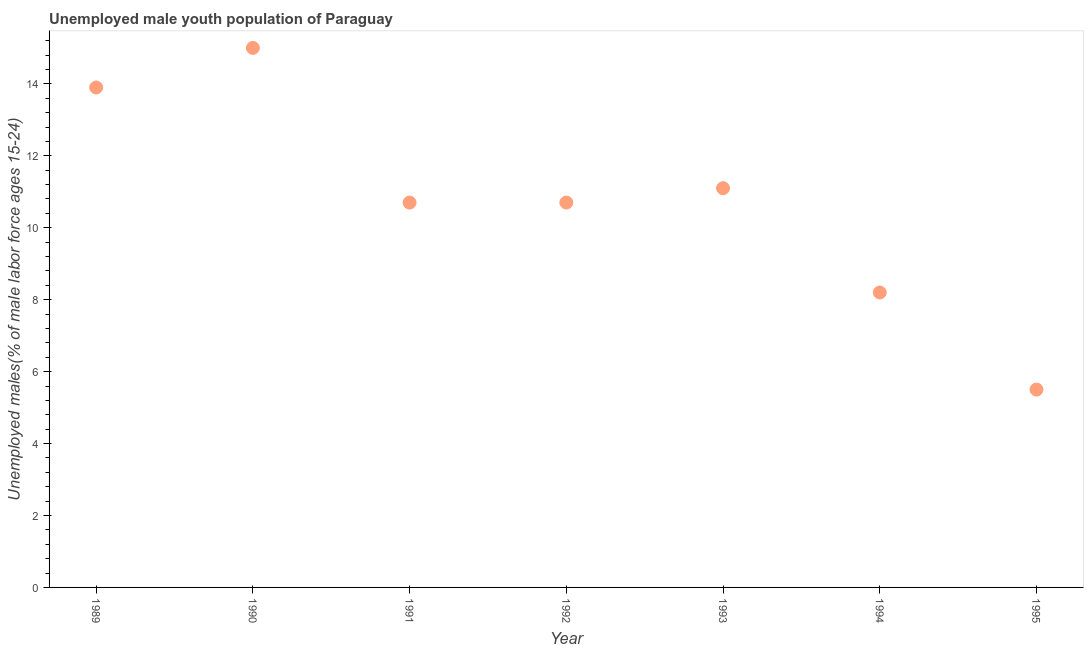What is the unemployed male youth in 1992?
Give a very brief answer. 10.7. Across all years, what is the minimum unemployed male youth?
Offer a terse response. 5.5. In which year was the unemployed male youth minimum?
Offer a terse response. 1995. What is the sum of the unemployed male youth?
Ensure brevity in your answer.  75.1. What is the difference between the unemployed male youth in 1989 and 1992?
Ensure brevity in your answer.  3.2. What is the average unemployed male youth per year?
Keep it short and to the point. 10.73. What is the median unemployed male youth?
Your answer should be compact. 10.7. Do a majority of the years between 1990 and 1994 (inclusive) have unemployed male youth greater than 5.2 %?
Your answer should be very brief. Yes. What is the ratio of the unemployed male youth in 1990 to that in 1993?
Your answer should be compact. 1.35. Is the unemployed male youth in 1991 less than that in 1992?
Your answer should be very brief. No. Is the difference between the unemployed male youth in 1990 and 1994 greater than the difference between any two years?
Keep it short and to the point. No. What is the difference between the highest and the second highest unemployed male youth?
Ensure brevity in your answer.  1.1. Is the sum of the unemployed male youth in 1989 and 1995 greater than the maximum unemployed male youth across all years?
Keep it short and to the point. Yes. How many dotlines are there?
Your response must be concise. 1. How many years are there in the graph?
Give a very brief answer. 7. What is the difference between two consecutive major ticks on the Y-axis?
Provide a short and direct response. 2. Does the graph contain any zero values?
Make the answer very short. No. What is the title of the graph?
Offer a terse response. Unemployed male youth population of Paraguay. What is the label or title of the Y-axis?
Offer a very short reply. Unemployed males(% of male labor force ages 15-24). What is the Unemployed males(% of male labor force ages 15-24) in 1989?
Give a very brief answer. 13.9. What is the Unemployed males(% of male labor force ages 15-24) in 1991?
Offer a terse response. 10.7. What is the Unemployed males(% of male labor force ages 15-24) in 1992?
Ensure brevity in your answer.  10.7. What is the Unemployed males(% of male labor force ages 15-24) in 1993?
Give a very brief answer. 11.1. What is the Unemployed males(% of male labor force ages 15-24) in 1994?
Your response must be concise. 8.2. What is the Unemployed males(% of male labor force ages 15-24) in 1995?
Give a very brief answer. 5.5. What is the difference between the Unemployed males(% of male labor force ages 15-24) in 1989 and 1995?
Your response must be concise. 8.4. What is the difference between the Unemployed males(% of male labor force ages 15-24) in 1990 and 1991?
Keep it short and to the point. 4.3. What is the difference between the Unemployed males(% of male labor force ages 15-24) in 1990 and 1992?
Offer a very short reply. 4.3. What is the difference between the Unemployed males(% of male labor force ages 15-24) in 1990 and 1993?
Your answer should be compact. 3.9. What is the difference between the Unemployed males(% of male labor force ages 15-24) in 1991 and 1993?
Make the answer very short. -0.4. What is the difference between the Unemployed males(% of male labor force ages 15-24) in 1992 and 1994?
Keep it short and to the point. 2.5. What is the difference between the Unemployed males(% of male labor force ages 15-24) in 1993 and 1995?
Your answer should be compact. 5.6. What is the difference between the Unemployed males(% of male labor force ages 15-24) in 1994 and 1995?
Your answer should be compact. 2.7. What is the ratio of the Unemployed males(% of male labor force ages 15-24) in 1989 to that in 1990?
Ensure brevity in your answer.  0.93. What is the ratio of the Unemployed males(% of male labor force ages 15-24) in 1989 to that in 1991?
Your answer should be very brief. 1.3. What is the ratio of the Unemployed males(% of male labor force ages 15-24) in 1989 to that in 1992?
Provide a succinct answer. 1.3. What is the ratio of the Unemployed males(% of male labor force ages 15-24) in 1989 to that in 1993?
Offer a very short reply. 1.25. What is the ratio of the Unemployed males(% of male labor force ages 15-24) in 1989 to that in 1994?
Your answer should be compact. 1.7. What is the ratio of the Unemployed males(% of male labor force ages 15-24) in 1989 to that in 1995?
Provide a succinct answer. 2.53. What is the ratio of the Unemployed males(% of male labor force ages 15-24) in 1990 to that in 1991?
Keep it short and to the point. 1.4. What is the ratio of the Unemployed males(% of male labor force ages 15-24) in 1990 to that in 1992?
Offer a very short reply. 1.4. What is the ratio of the Unemployed males(% of male labor force ages 15-24) in 1990 to that in 1993?
Your answer should be very brief. 1.35. What is the ratio of the Unemployed males(% of male labor force ages 15-24) in 1990 to that in 1994?
Your answer should be very brief. 1.83. What is the ratio of the Unemployed males(% of male labor force ages 15-24) in 1990 to that in 1995?
Give a very brief answer. 2.73. What is the ratio of the Unemployed males(% of male labor force ages 15-24) in 1991 to that in 1992?
Offer a very short reply. 1. What is the ratio of the Unemployed males(% of male labor force ages 15-24) in 1991 to that in 1994?
Your response must be concise. 1.3. What is the ratio of the Unemployed males(% of male labor force ages 15-24) in 1991 to that in 1995?
Provide a short and direct response. 1.95. What is the ratio of the Unemployed males(% of male labor force ages 15-24) in 1992 to that in 1994?
Your response must be concise. 1.3. What is the ratio of the Unemployed males(% of male labor force ages 15-24) in 1992 to that in 1995?
Your answer should be very brief. 1.95. What is the ratio of the Unemployed males(% of male labor force ages 15-24) in 1993 to that in 1994?
Your answer should be compact. 1.35. What is the ratio of the Unemployed males(% of male labor force ages 15-24) in 1993 to that in 1995?
Give a very brief answer. 2.02. What is the ratio of the Unemployed males(% of male labor force ages 15-24) in 1994 to that in 1995?
Your answer should be compact. 1.49. 